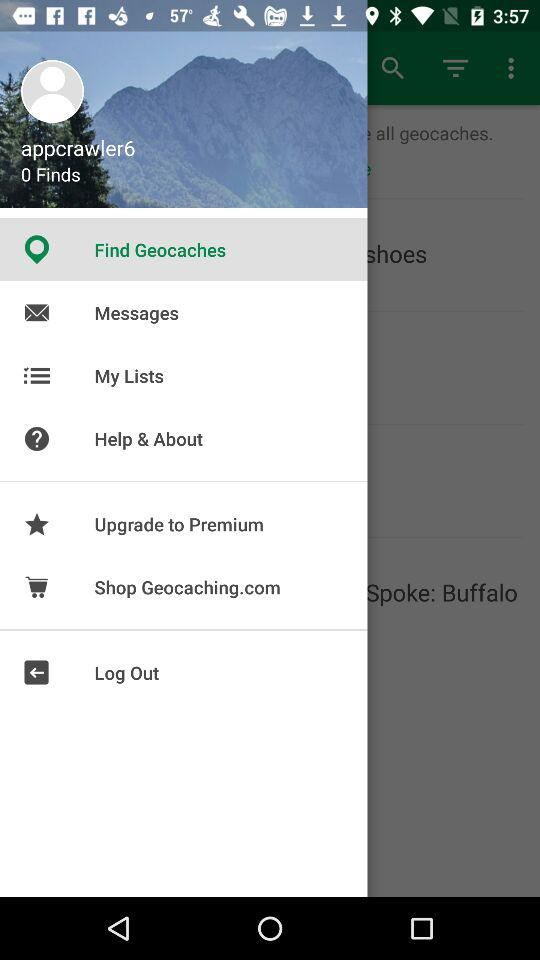What is the username? The username is "appcrawler6". 